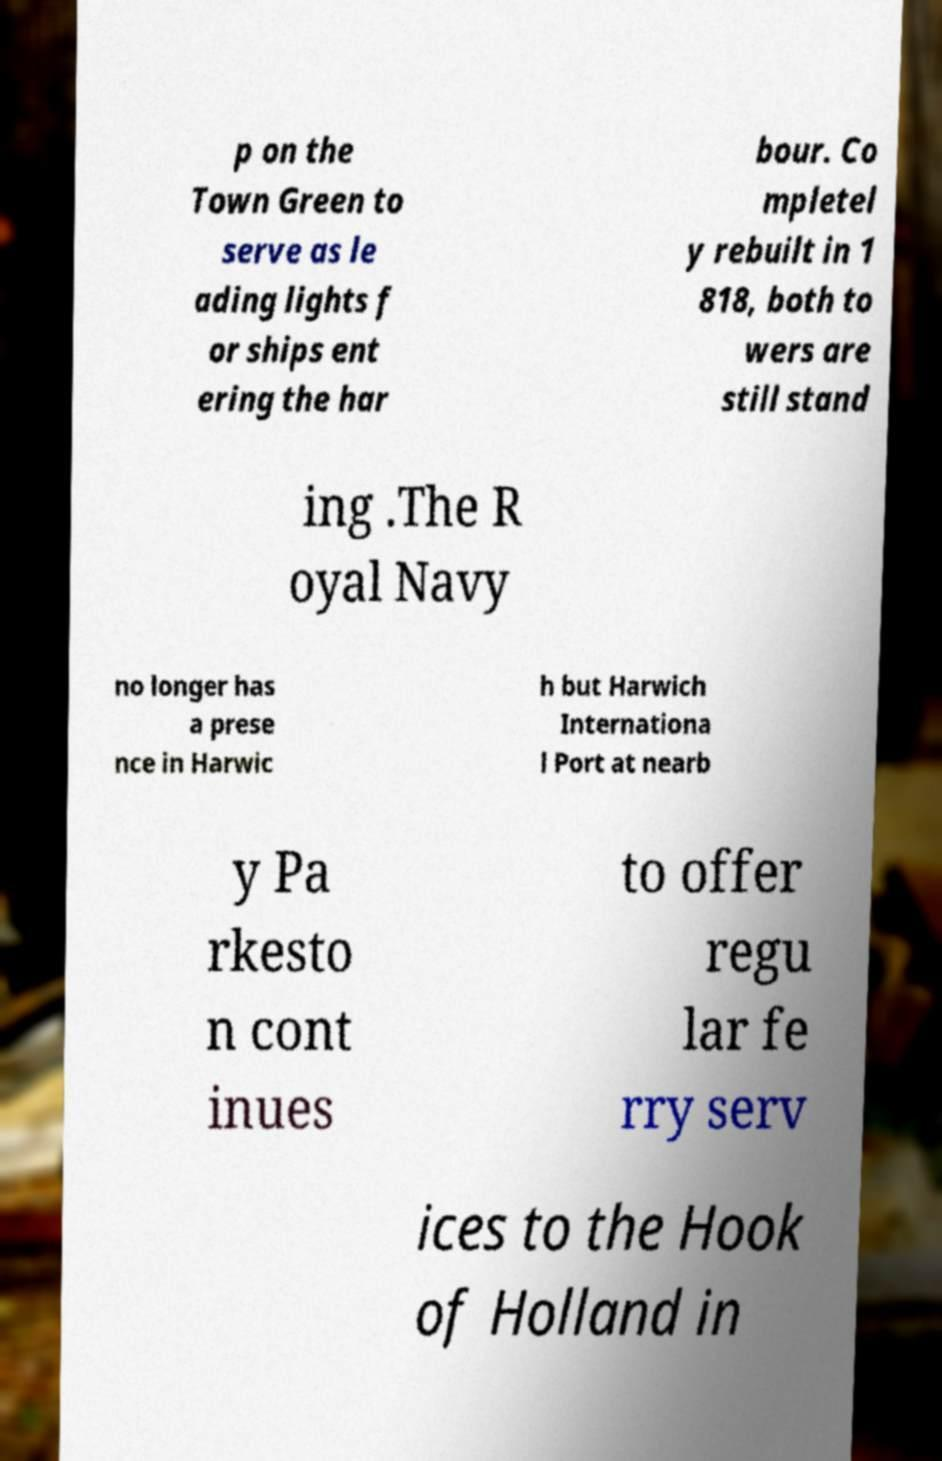Please read and relay the text visible in this image. What does it say? p on the Town Green to serve as le ading lights f or ships ent ering the har bour. Co mpletel y rebuilt in 1 818, both to wers are still stand ing .The R oyal Navy no longer has a prese nce in Harwic h but Harwich Internationa l Port at nearb y Pa rkesto n cont inues to offer regu lar fe rry serv ices to the Hook of Holland in 